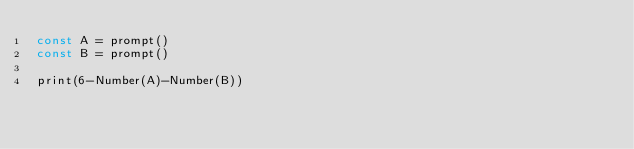Convert code to text. <code><loc_0><loc_0><loc_500><loc_500><_JavaScript_>const A = prompt()
const B = prompt()

print(6-Number(A)-Number(B))</code> 